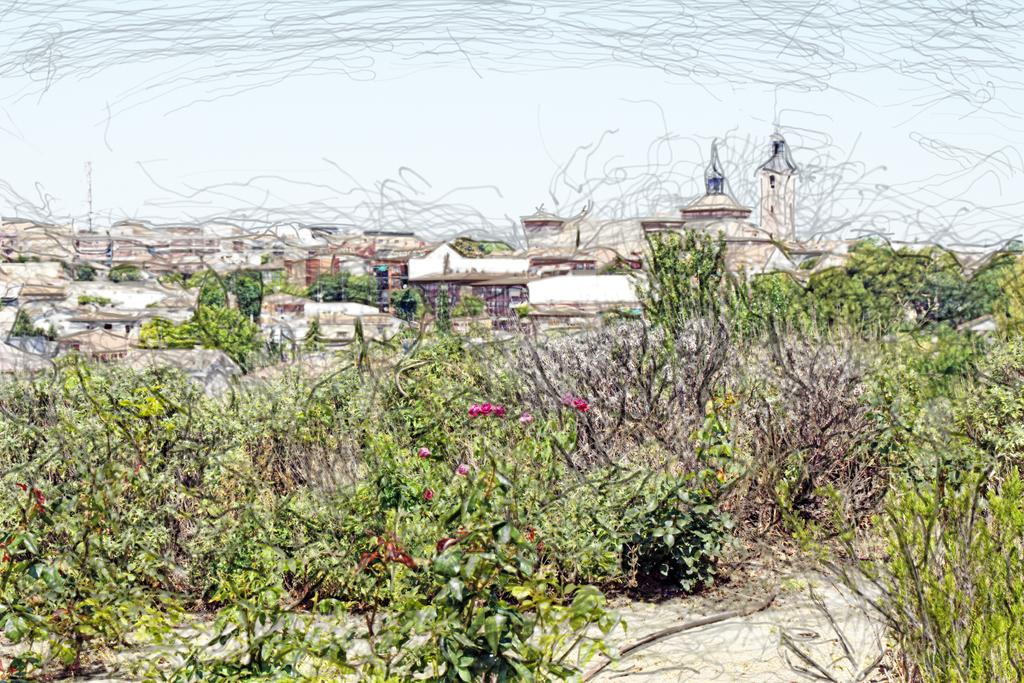What type of plants can be seen in the image? There are houseplants in the image. What part of the natural environment is visible in the image? The sky is visible in the image. What type of whip is being used by the person in the image? There is no person or whip present in the image; it only features houseplants and the sky. 